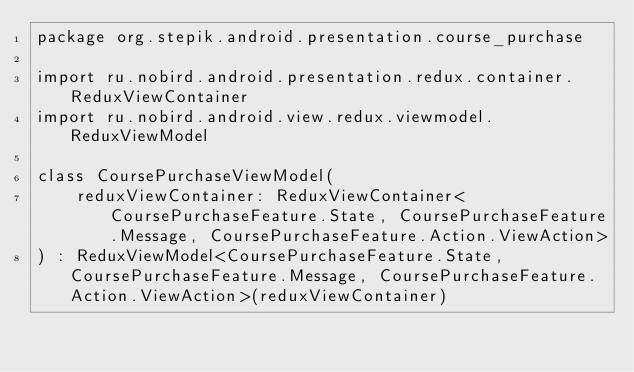Convert code to text. <code><loc_0><loc_0><loc_500><loc_500><_Kotlin_>package org.stepik.android.presentation.course_purchase

import ru.nobird.android.presentation.redux.container.ReduxViewContainer
import ru.nobird.android.view.redux.viewmodel.ReduxViewModel

class CoursePurchaseViewModel(
    reduxViewContainer: ReduxViewContainer<CoursePurchaseFeature.State, CoursePurchaseFeature.Message, CoursePurchaseFeature.Action.ViewAction>
) : ReduxViewModel<CoursePurchaseFeature.State, CoursePurchaseFeature.Message, CoursePurchaseFeature.Action.ViewAction>(reduxViewContainer)</code> 